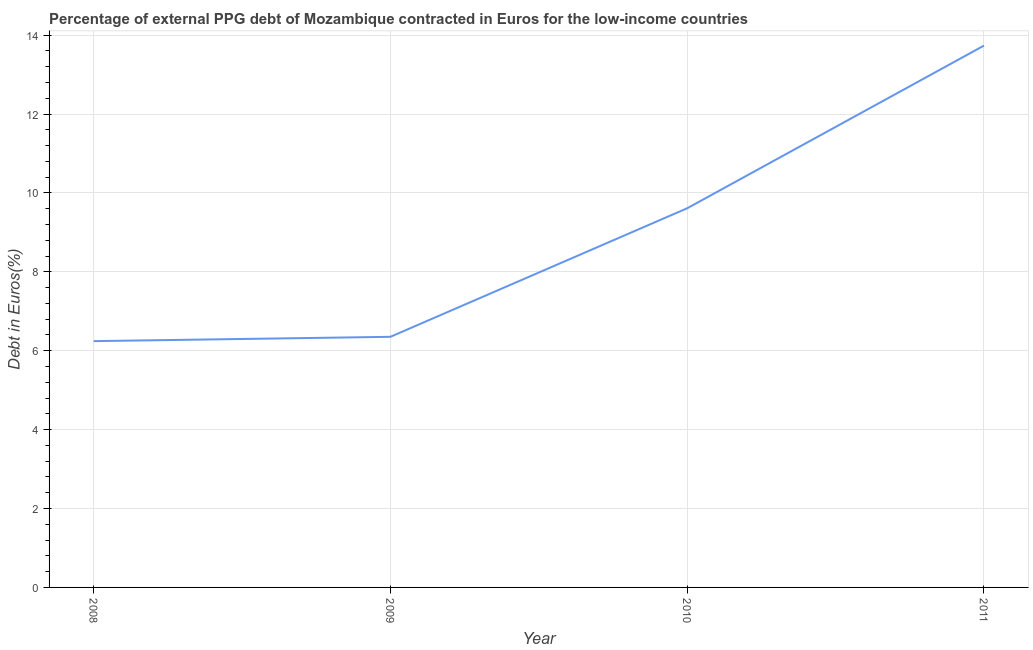What is the currency composition of ppg debt in 2011?
Your answer should be very brief. 13.73. Across all years, what is the maximum currency composition of ppg debt?
Provide a short and direct response. 13.73. Across all years, what is the minimum currency composition of ppg debt?
Keep it short and to the point. 6.24. What is the sum of the currency composition of ppg debt?
Provide a succinct answer. 35.94. What is the difference between the currency composition of ppg debt in 2010 and 2011?
Offer a very short reply. -4.12. What is the average currency composition of ppg debt per year?
Keep it short and to the point. 8.98. What is the median currency composition of ppg debt?
Your answer should be very brief. 7.98. What is the ratio of the currency composition of ppg debt in 2008 to that in 2011?
Keep it short and to the point. 0.45. Is the currency composition of ppg debt in 2008 less than that in 2011?
Provide a succinct answer. Yes. What is the difference between the highest and the second highest currency composition of ppg debt?
Make the answer very short. 4.12. What is the difference between the highest and the lowest currency composition of ppg debt?
Your answer should be compact. 7.49. In how many years, is the currency composition of ppg debt greater than the average currency composition of ppg debt taken over all years?
Your response must be concise. 2. How many lines are there?
Your answer should be very brief. 1. What is the difference between two consecutive major ticks on the Y-axis?
Your answer should be very brief. 2. Are the values on the major ticks of Y-axis written in scientific E-notation?
Keep it short and to the point. No. Does the graph contain any zero values?
Offer a very short reply. No. What is the title of the graph?
Offer a terse response. Percentage of external PPG debt of Mozambique contracted in Euros for the low-income countries. What is the label or title of the Y-axis?
Your response must be concise. Debt in Euros(%). What is the Debt in Euros(%) of 2008?
Give a very brief answer. 6.24. What is the Debt in Euros(%) of 2009?
Offer a terse response. 6.35. What is the Debt in Euros(%) of 2010?
Your answer should be very brief. 9.61. What is the Debt in Euros(%) in 2011?
Ensure brevity in your answer.  13.73. What is the difference between the Debt in Euros(%) in 2008 and 2009?
Offer a terse response. -0.11. What is the difference between the Debt in Euros(%) in 2008 and 2010?
Provide a short and direct response. -3.37. What is the difference between the Debt in Euros(%) in 2008 and 2011?
Your answer should be very brief. -7.49. What is the difference between the Debt in Euros(%) in 2009 and 2010?
Offer a very short reply. -3.26. What is the difference between the Debt in Euros(%) in 2009 and 2011?
Ensure brevity in your answer.  -7.38. What is the difference between the Debt in Euros(%) in 2010 and 2011?
Your answer should be compact. -4.12. What is the ratio of the Debt in Euros(%) in 2008 to that in 2009?
Provide a short and direct response. 0.98. What is the ratio of the Debt in Euros(%) in 2008 to that in 2010?
Provide a short and direct response. 0.65. What is the ratio of the Debt in Euros(%) in 2008 to that in 2011?
Your response must be concise. 0.46. What is the ratio of the Debt in Euros(%) in 2009 to that in 2010?
Ensure brevity in your answer.  0.66. What is the ratio of the Debt in Euros(%) in 2009 to that in 2011?
Your answer should be very brief. 0.46. What is the ratio of the Debt in Euros(%) in 2010 to that in 2011?
Your response must be concise. 0.7. 